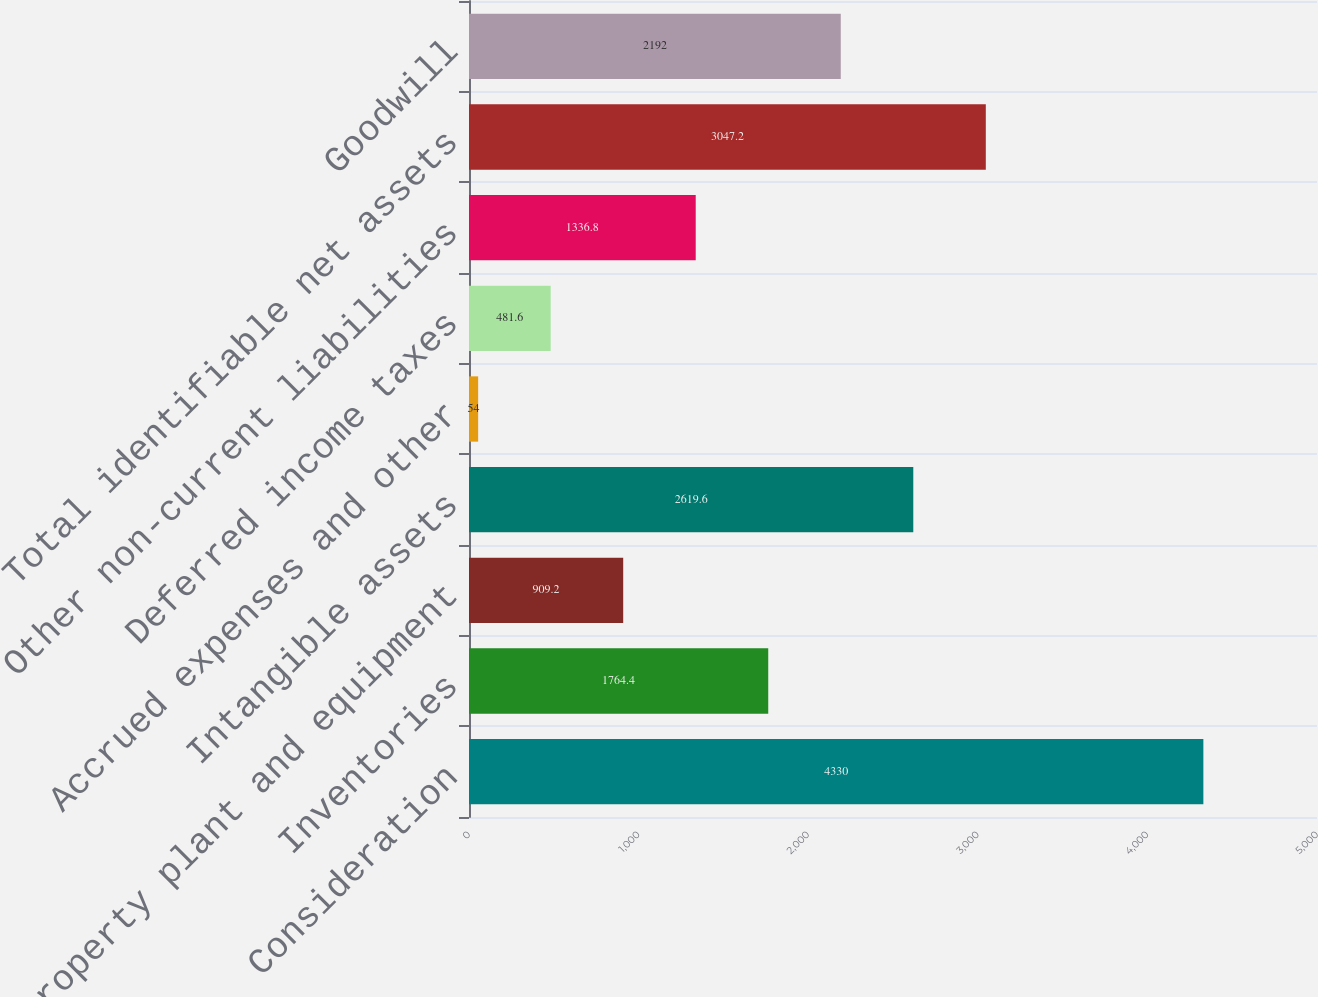<chart> <loc_0><loc_0><loc_500><loc_500><bar_chart><fcel>Consideration<fcel>Inventories<fcel>Property plant and equipment<fcel>Intangible assets<fcel>Accrued expenses and other<fcel>Deferred income taxes<fcel>Other non-current liabilities<fcel>Total identifiable net assets<fcel>Goodwill<nl><fcel>4330<fcel>1764.4<fcel>909.2<fcel>2619.6<fcel>54<fcel>481.6<fcel>1336.8<fcel>3047.2<fcel>2192<nl></chart> 